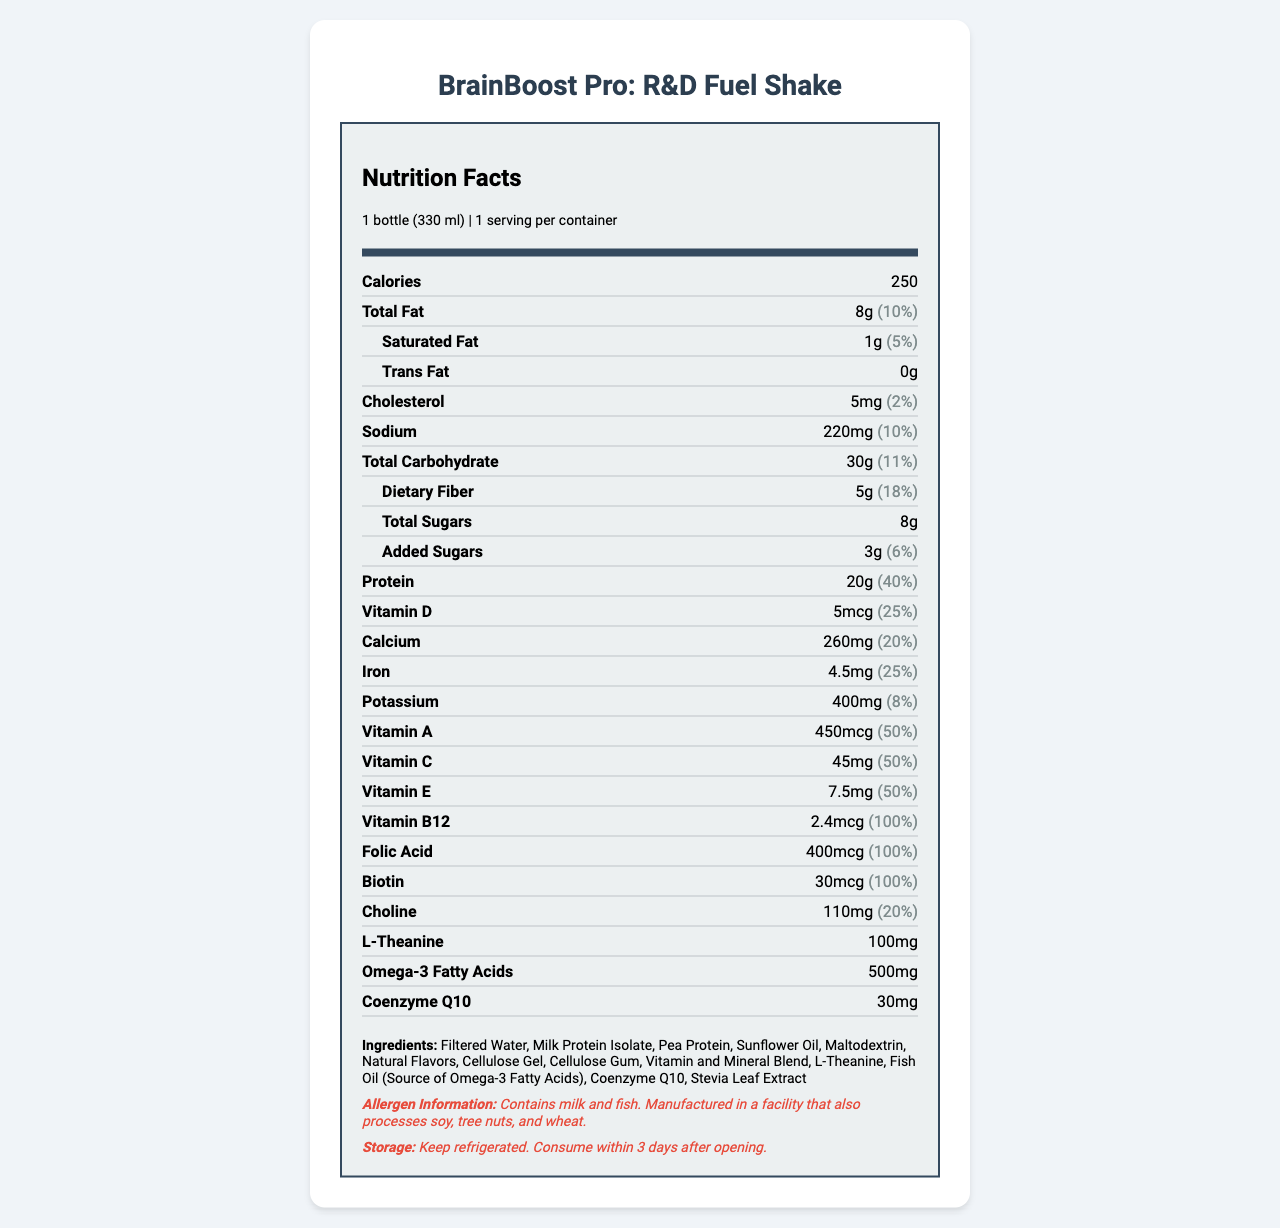what is the serving size for BrainBoost Pro: R&D Fuel Shake? The label specifies that the serving size is 1 bottle, which is equivalent to 330 ml.
Answer: 1 bottle (330 ml) how many calories are in a serving of BrainBoost Pro: R&D Fuel Shake? The label states that there are 250 calories per serving.
Answer: 250 calories what is the percentage of daily value for total fat in BrainBoost Pro: R&D Fuel Shake? The label indicates that the total fat content in one serving is 8g, which is 10% of the daily value.
Answer: 10% how much protein is in a serving of BrainBoost Pro: R&D Fuel Shake? The label shows that one serving contains 20g of protein.
Answer: 20g what allergens are present in BrainBoost Pro: R&D Fuel Shake? The allergen information section on the label lists milk and fish as present allergens.
Answer: Contains milk and fish which vitamin in BrainBoost Pro: R&D Fuel Shake has a daily value of 100%? A. Vitamin D B. Vitamin A C. Vitamin B12 D. Calcium The label states that Vitamin B12 has a daily value of 100%.
Answer: C. Vitamin B12 how much dietary fiber does BrainBoost Pro: R&D Fuel Shake provide? A. 2g B. 5g C. 8g D. 10g The label indicates that each serving contains 5g of dietary fiber, which is 18% of the daily value.
Answer: B. 5g does BrainBoost Pro: R&D Fuel Shake contain trans fat? Yes/No The label specifically states that there is 0g of trans fat per serving.
Answer: No summarize the main nutrients and added ingredients in BrainBoost Pro: R&D Fuel Shake. The label presents detailed nutritional information including macronutrients, dietary fiber, sugars, and minerals, with specific mention of vitamins like Vitamin D, A, C, and special ingredients such as Omega-3 fatty acids and Coenzyme Q10. Allergen and storage information are also provided.
Answer: It contains macronutrients like 250 calories, 8g of total fat, 30g of total carbohydrates, and 20g of protein. It also includes a rich blend of vitamins and minerals, Omega-3 fatty acids, L-Theanine, and Coenzyme Q10. The shake has milk and fish allergens. does BrainBoost Pro: R&D Fuel Shake contain soy? The allergen information mentions that it is manufactured in a facility that processes soy, but it does not specify whether soy is an ingredient in the shake itself.
Answer: Cannot be determined how long should BrainBoost Pro: R&D Fuel Shake be consumed after opening? The storage information on the label advises consuming the product within 3 days after opening.
Answer: Within 3 days how much Vitamin C does BrainBoost Pro: R&D Fuel Shake provide compared to the daily value percentage? The nutrition label shows that one serving contains 45mg of Vitamin C, which is 50% of the daily value.
Answer: 45mg, 50% what is the amount of Omega-3 fatty acids in BrainBoost Pro: R&D Fuel Shake? The label lists 500mg of Omega-3 fatty acids as part of the nutritional content.
Answer: 500mg how much choline is there in a serving of BrainBoost Pro: R&D Fuel Shake? The label indicates that a serving includes 110mg of choline, which is 20% of the daily value.
Answer: 110mg what type of extract is used as a sweetener in BrainBoost Pro: R&D Fuel Shake? The list of ingredients includes Stevia Leaf Extract as one of the components used in the shake.
Answer: Stevia Leaf Extract how much added sugars does BrainBoost Pro: R&D Fuel Shake provide? A. 5g B. 3g C. 8g D. 2g The label indicates that the shake contains 3g of added sugars, which is 6% of the daily value.
Answer: B. 3g 